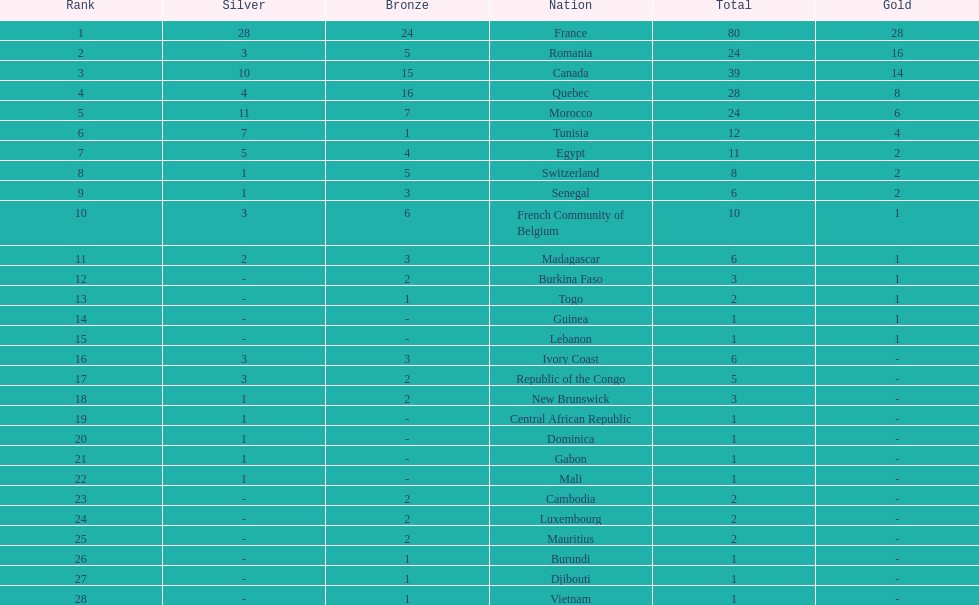What was the total medal count of switzerland? 8. Parse the table in full. {'header': ['Rank', 'Silver', 'Bronze', 'Nation', 'Total', 'Gold'], 'rows': [['1', '28', '24', 'France', '80', '28'], ['2', '3', '5', 'Romania', '24', '16'], ['3', '10', '15', 'Canada', '39', '14'], ['4', '4', '16', 'Quebec', '28', '8'], ['5', '11', '7', 'Morocco', '24', '6'], ['6', '7', '1', 'Tunisia', '12', '4'], ['7', '5', '4', 'Egypt', '11', '2'], ['8', '1', '5', 'Switzerland', '8', '2'], ['9', '1', '3', 'Senegal', '6', '2'], ['10', '3', '6', 'French Community of Belgium', '10', '1'], ['11', '2', '3', 'Madagascar', '6', '1'], ['12', '-', '2', 'Burkina Faso', '3', '1'], ['13', '-', '1', 'Togo', '2', '1'], ['14', '-', '-', 'Guinea', '1', '1'], ['15', '-', '-', 'Lebanon', '1', '1'], ['16', '3', '3', 'Ivory Coast', '6', '-'], ['17', '3', '2', 'Republic of the Congo', '5', '-'], ['18', '1', '2', 'New Brunswick', '3', '-'], ['19', '1', '-', 'Central African Republic', '1', '-'], ['20', '1', '-', 'Dominica', '1', '-'], ['21', '1', '-', 'Gabon', '1', '-'], ['22', '1', '-', 'Mali', '1', '-'], ['23', '-', '2', 'Cambodia', '2', '-'], ['24', '-', '2', 'Luxembourg', '2', '-'], ['25', '-', '2', 'Mauritius', '2', '-'], ['26', '-', '1', 'Burundi', '1', '-'], ['27', '-', '1', 'Djibouti', '1', '-'], ['28', '-', '1', 'Vietnam', '1', '-']]} 